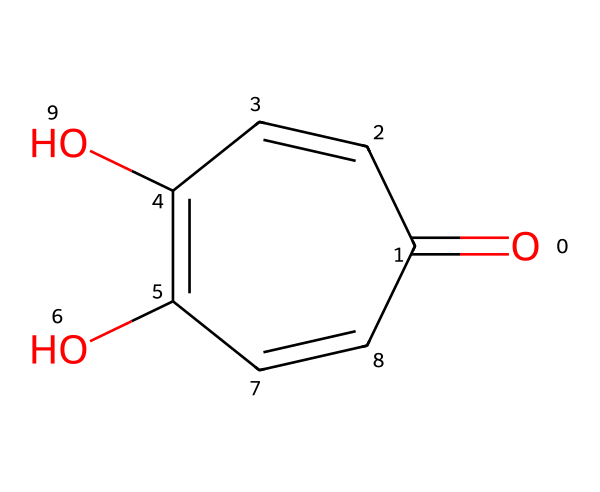What is the main functional group present in this structure? The chemical structure contains multiple hydroxyl groups (-OH) and a carbonyl group (C=O). Thus, the main functional group is the hydroxyl group, which is indicative of the chemical's functional characteristics.
Answer: hydroxyl group How many rings are present in the structure? The structure consists of a fused bicyclic ring system, indicating that there are two interconnected rings formed.
Answer: two What type of bond predominates in the rings of this chemical? The rings contain alternating single and double bonds characteristic of aromatic compounds, leading to the conclusion that the predominant bond type in the rings is the double bond due to resonance stabilization.
Answer: double bond Which property of graphene oxide enhances its application in water filtration? The presence of -OH and -CO groups in graphene oxide increases hydrophilicity, which improves interactions with water and helps in the adsorption of contaminants, thereby enhancing its application in water filtration.
Answer: hydrophilicity Are there any chiral centers in this structure? Assessing the structure reveals that there are no carbon atoms that are bonded to four different substituents, confirming the absence of chiral centers in this chemical.
Answer: no What is the significance of the carbonyl functional group in this nanomaterial? The carbonyl functional group (C=O) is crucial for reactivity and can engage in hydrogen bonding, enhancing the material's ability to interact with various species in water filtration, which is vital for effective contaminant removal.
Answer: reactivity 